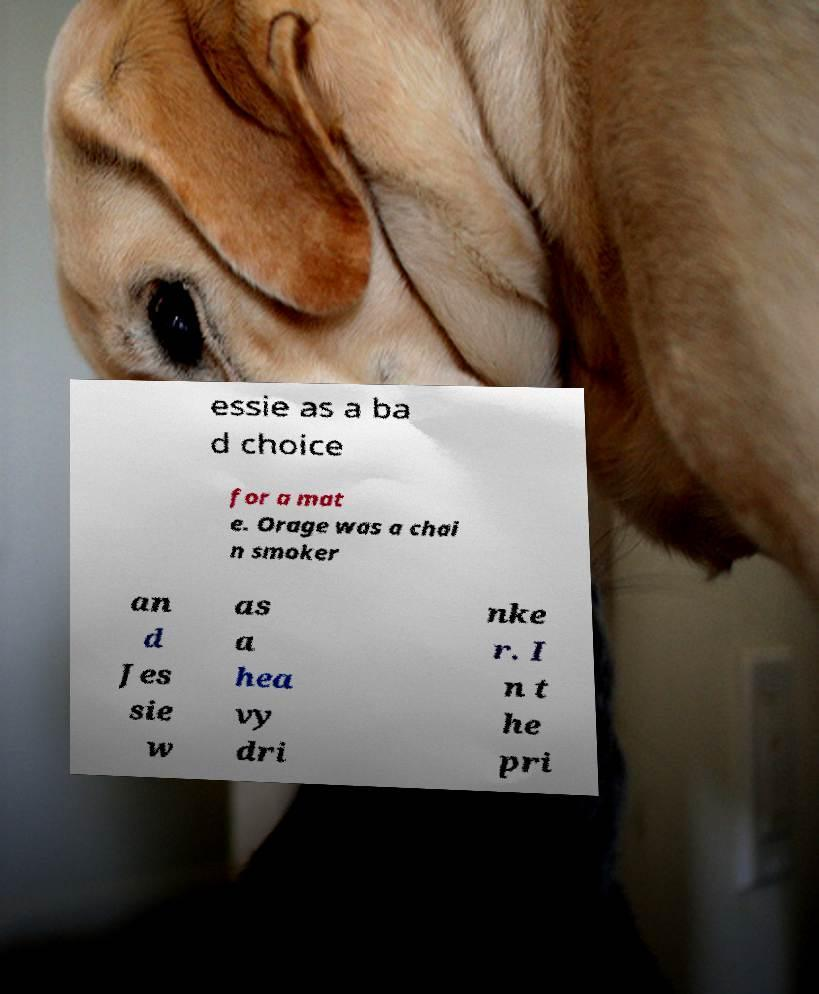Please identify and transcribe the text found in this image. essie as a ba d choice for a mat e. Orage was a chai n smoker an d Jes sie w as a hea vy dri nke r. I n t he pri 